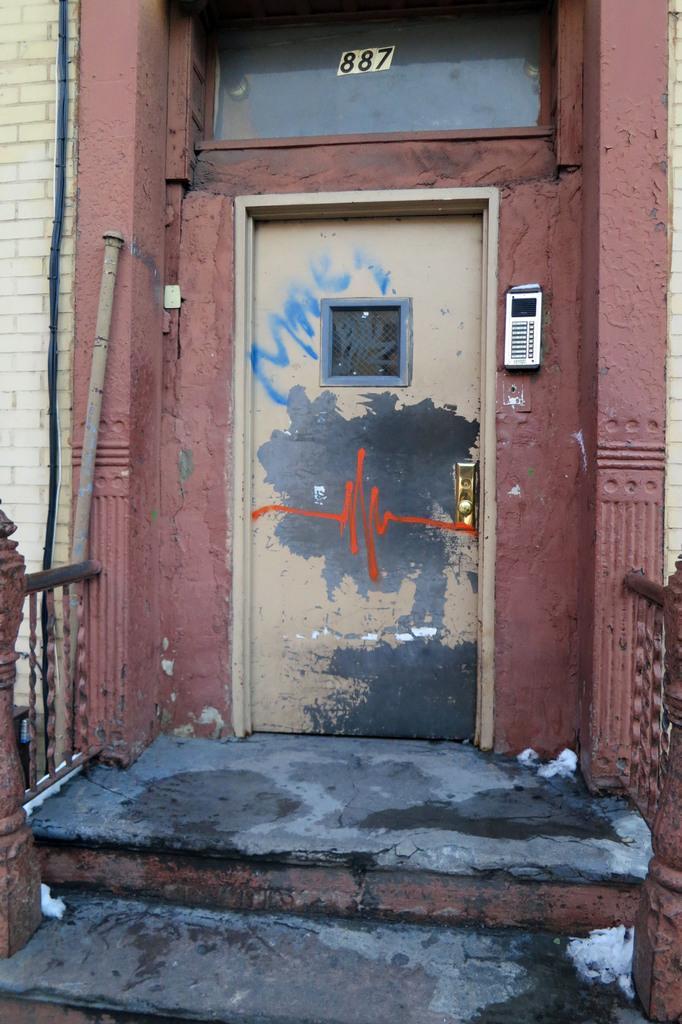Please provide a concise description of this image. In this given picture, we can see the floor and a door after that, we can see a window, an electronic gadget fixed to the wall next, we can see an iron metal pole and electrical wire finally, we can see a wall and the iron metal grill. 